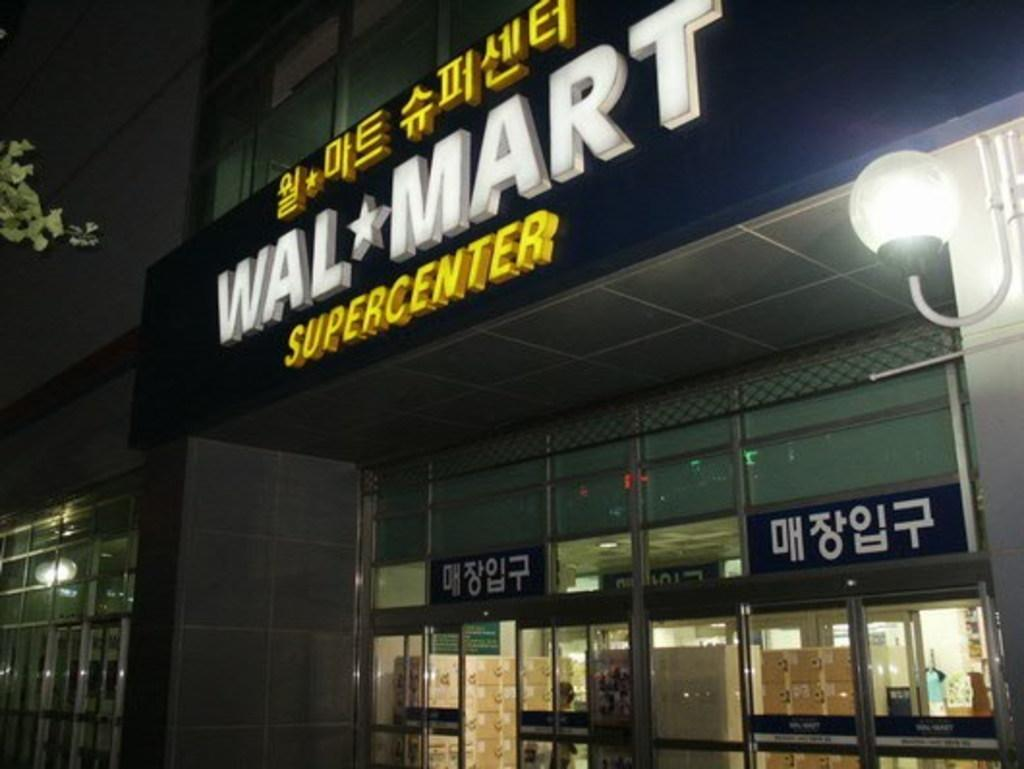What type of structures can be seen in the image? There are buildings in the image. What else is visible in the image besides the buildings? There are lights, boards, cardboard boxes, and a tree in the image. What is the color of the sky in the background of the image? The sky is dark in the background of the image. What type of cork can be seen in the image? There is no cork present in the image. What is the tendency of the cardboard boxes in the image? The provided facts do not give information about the tendency of the cardboard boxes, so this question cannot be definitively answered. 